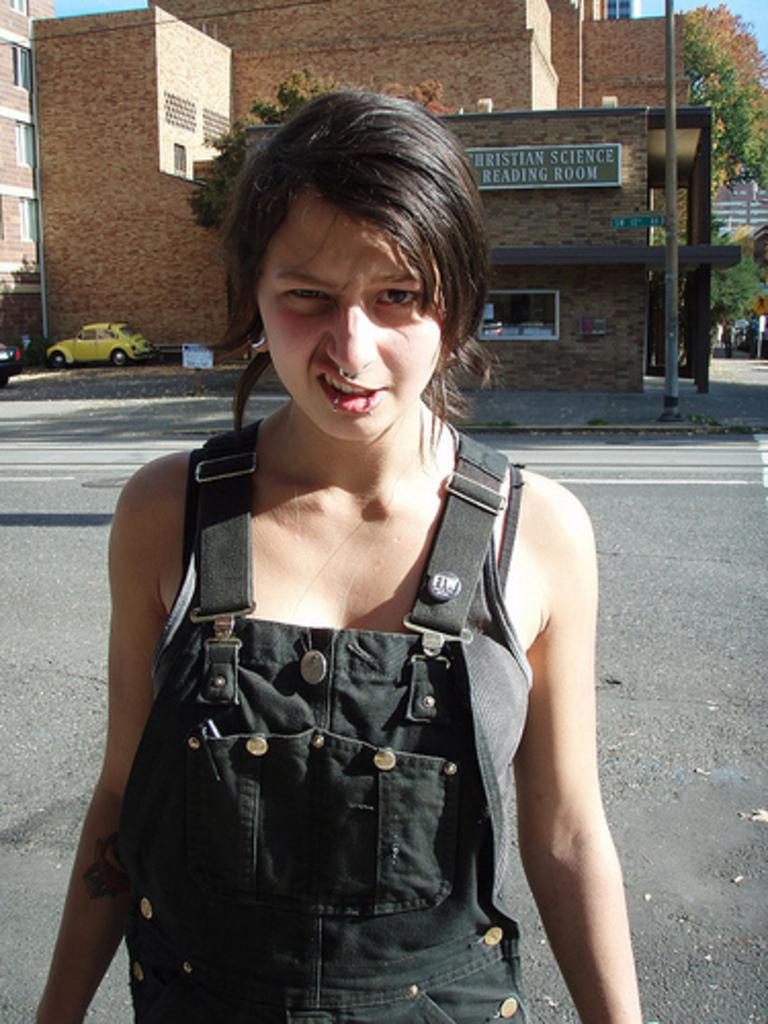Who is the main subject in the image? There is a woman standing in the front of the image. What can be seen in the background of the image? There are buildings, windows, a banner, a yellow color car, trees, and the sky visible in the background. How many ladybugs are crawling on the banner in the image? There are no ladybugs present in the image; the banner is the only element mentioned in the background. 